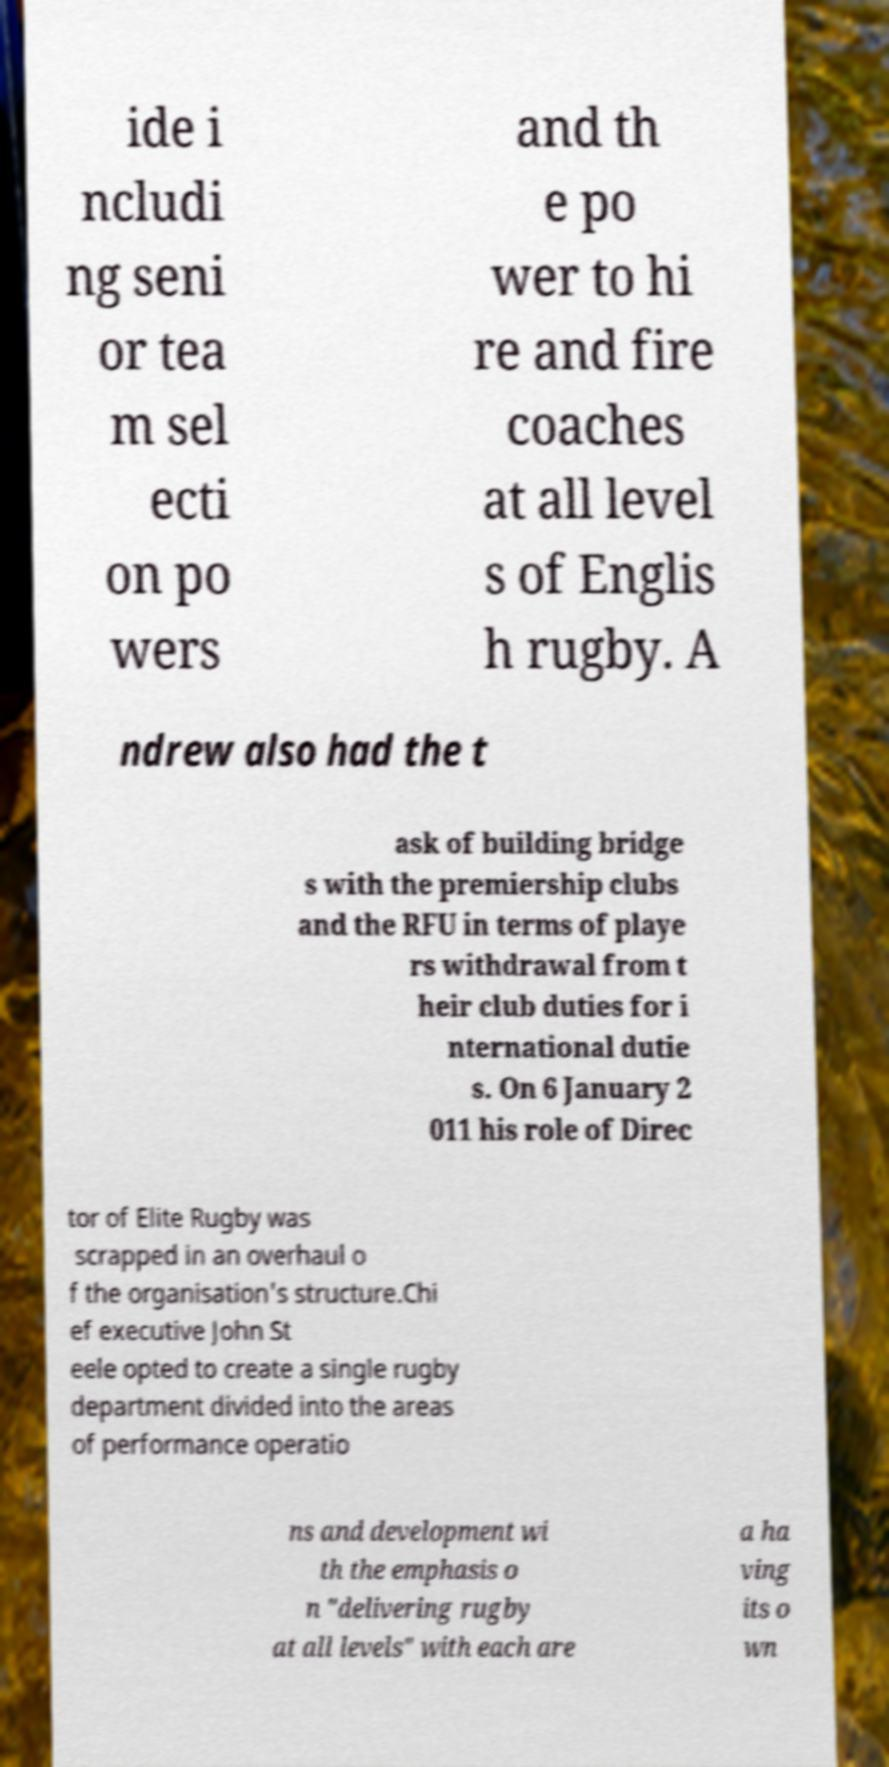Could you extract and type out the text from this image? ide i ncludi ng seni or tea m sel ecti on po wers and th e po wer to hi re and fire coaches at all level s of Englis h rugby. A ndrew also had the t ask of building bridge s with the premiership clubs and the RFU in terms of playe rs withdrawal from t heir club duties for i nternational dutie s. On 6 January 2 011 his role of Direc tor of Elite Rugby was scrapped in an overhaul o f the organisation's structure.Chi ef executive John St eele opted to create a single rugby department divided into the areas of performance operatio ns and development wi th the emphasis o n "delivering rugby at all levels" with each are a ha ving its o wn 